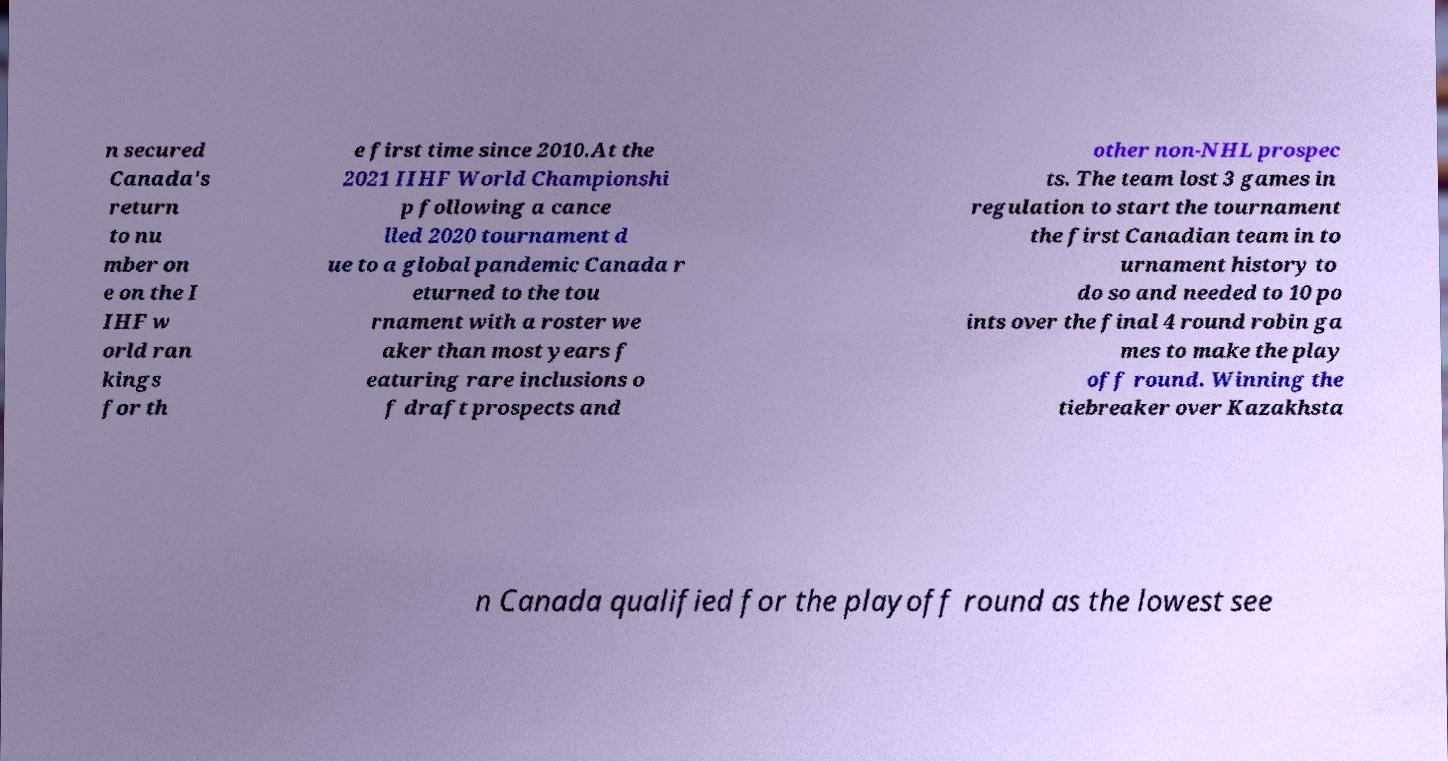Please identify and transcribe the text found in this image. n secured Canada's return to nu mber on e on the I IHF w orld ran kings for th e first time since 2010.At the 2021 IIHF World Championshi p following a cance lled 2020 tournament d ue to a global pandemic Canada r eturned to the tou rnament with a roster we aker than most years f eaturing rare inclusions o f draft prospects and other non-NHL prospec ts. The team lost 3 games in regulation to start the tournament the first Canadian team in to urnament history to do so and needed to 10 po ints over the final 4 round robin ga mes to make the play off round. Winning the tiebreaker over Kazakhsta n Canada qualified for the playoff round as the lowest see 